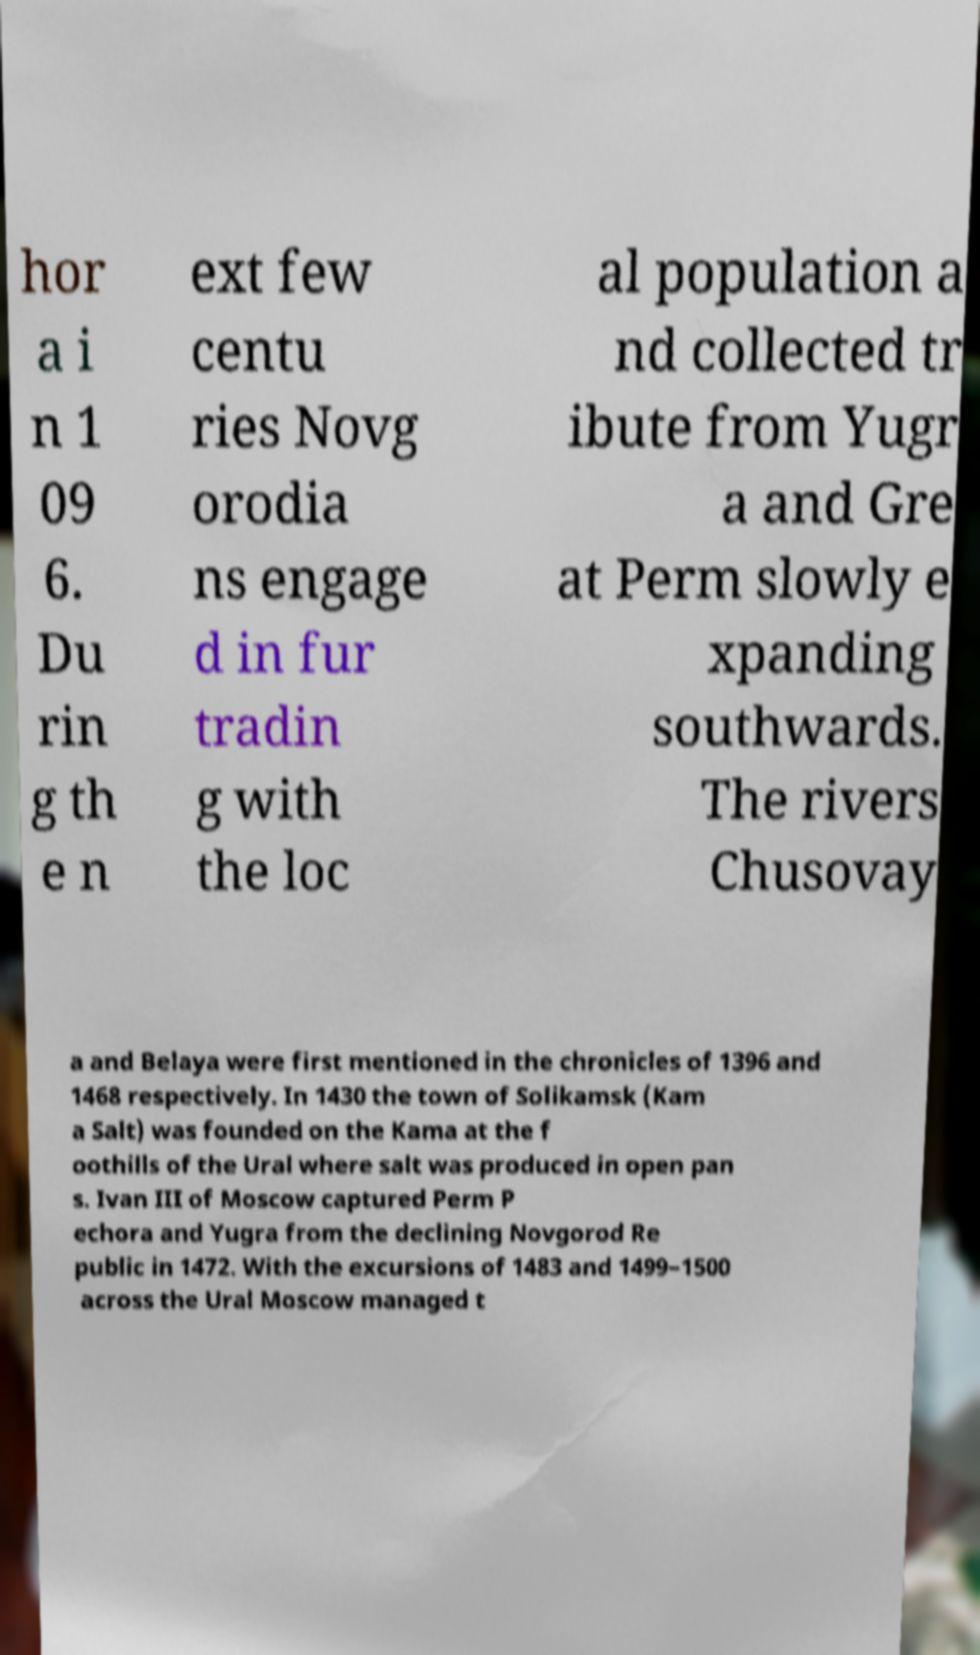I need the written content from this picture converted into text. Can you do that? hor a i n 1 09 6. Du rin g th e n ext few centu ries Novg orodia ns engage d in fur tradin g with the loc al population a nd collected tr ibute from Yugr a and Gre at Perm slowly e xpanding southwards. The rivers Chusovay a and Belaya were first mentioned in the chronicles of 1396 and 1468 respectively. In 1430 the town of Solikamsk (Kam a Salt) was founded on the Kama at the f oothills of the Ural where salt was produced in open pan s. Ivan III of Moscow captured Perm P echora and Yugra from the declining Novgorod Re public in 1472. With the excursions of 1483 and 1499–1500 across the Ural Moscow managed t 